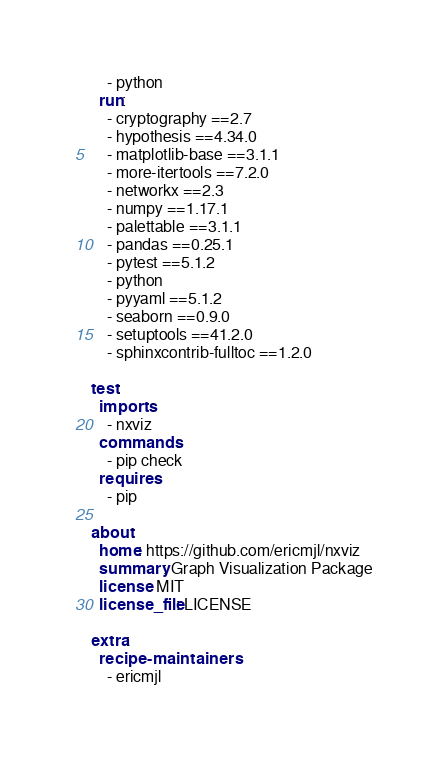<code> <loc_0><loc_0><loc_500><loc_500><_YAML_>    - python
  run:
    - cryptography ==2.7
    - hypothesis ==4.34.0
    - matplotlib-base ==3.1.1
    - more-itertools ==7.2.0
    - networkx ==2.3
    - numpy ==1.17.1
    - palettable ==3.1.1
    - pandas ==0.25.1
    - pytest ==5.1.2
    - python
    - pyyaml ==5.1.2
    - seaborn ==0.9.0
    - setuptools ==41.2.0
    - sphinxcontrib-fulltoc ==1.2.0

test:
  imports:
    - nxviz
  commands:
    - pip check
  requires:
    - pip

about:
  home: https://github.com/ericmjl/nxviz
  summary: Graph Visualization Package
  license: MIT
  license_file: LICENSE

extra:
  recipe-maintainers:
    - ericmjl
</code> 